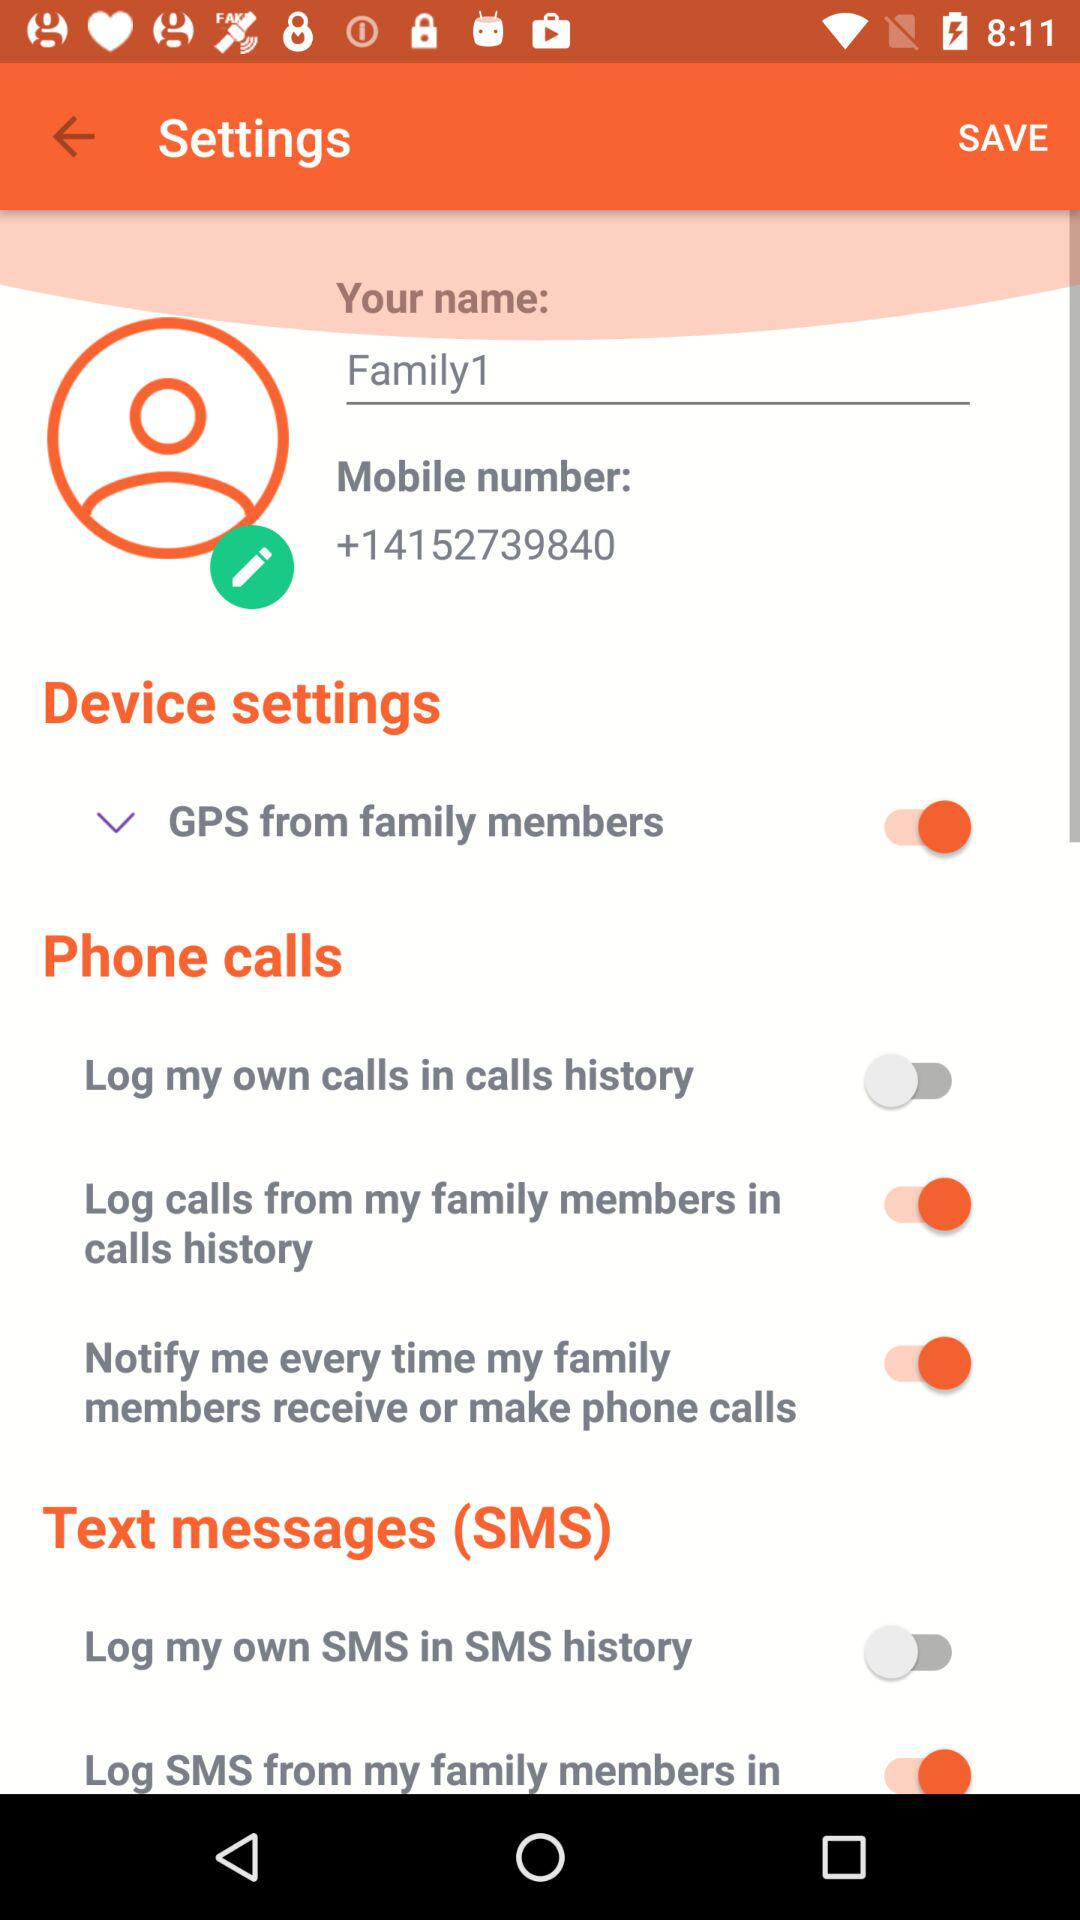What is the mentioned name here? The mentioned name is "Family1". 